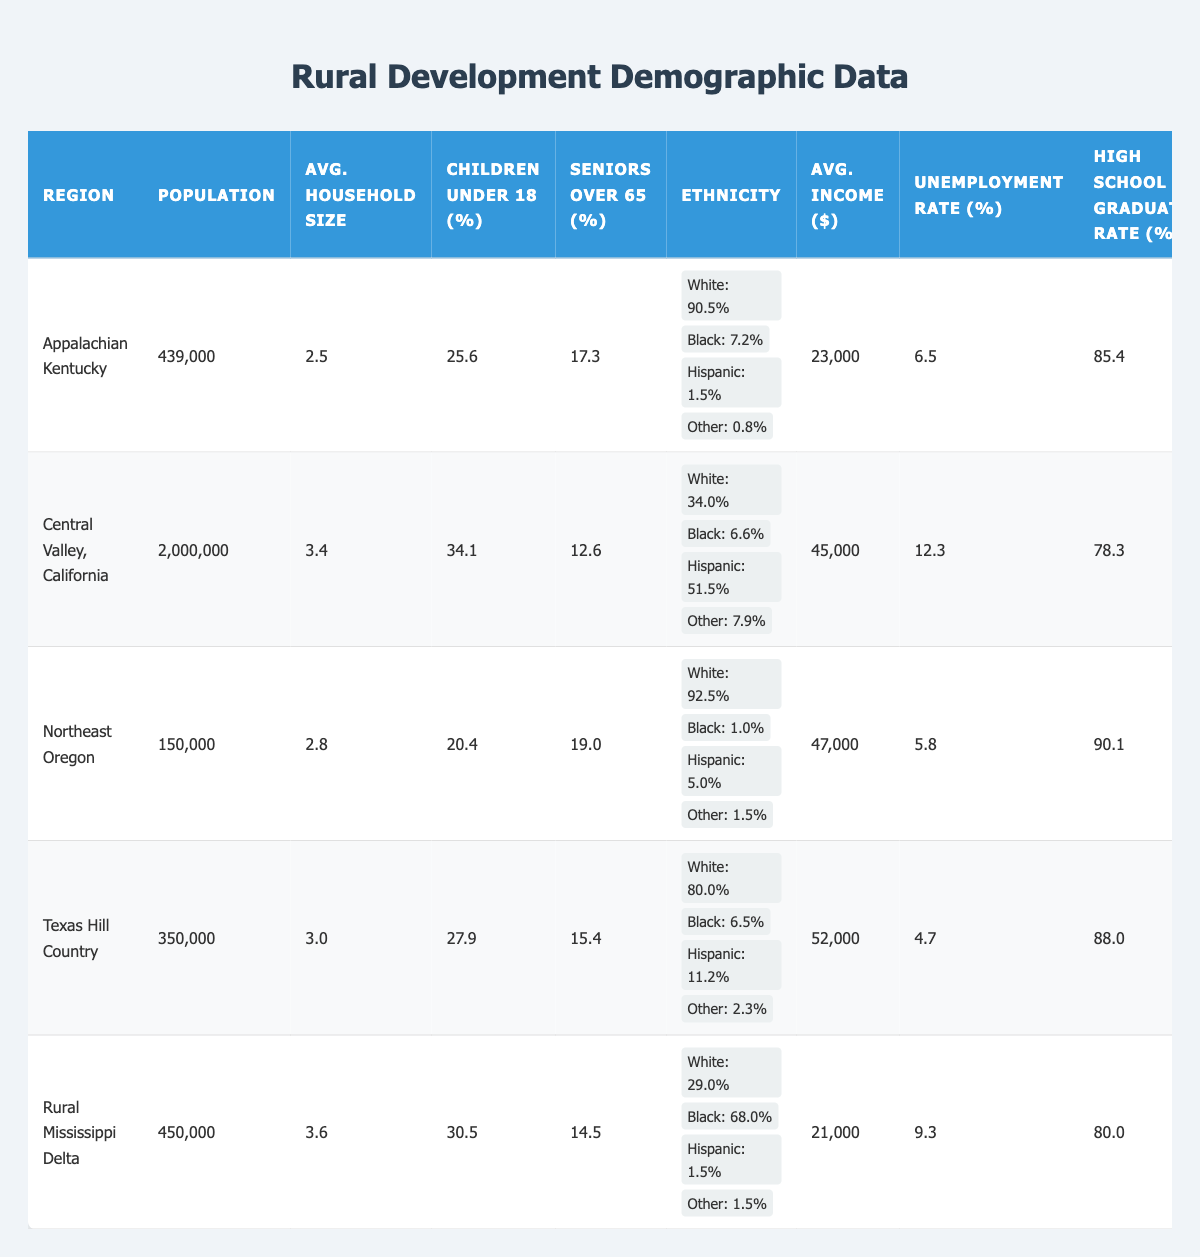What is the population of Central Valley, California? The table lists the population for each region. In the row for Central Valley, California, the population is recorded as 2,000,000.
Answer: 2,000,000 What is the average household size in the Texas Hill Country? Looking at the Texas Hill Country row in the table, the average household size is given as 3.0.
Answer: 3.0 Which region has the highest percentage of children under 18? By comparing the values in the "Children Under 18 (%)" column, the Rural Mississippi Delta has the highest value at 30.5%.
Answer: Rural Mississippi Delta What is the poverty rate in Appalachian Kentucky? Checking the poverty rate for Appalachian Kentucky in the table, it shows a rate of 30.2%.
Answer: 30.2% Which region has the lowest unemployment rate? In the "Unemployment Rate (%)" column, Texas Hill Country shows the lowest rate at 4.7%, which is lower than all other regions.
Answer: Texas Hill Country Is the percentage of seniors over 65 in Northeast Oregon greater than 15%? The table shows that the percentage of seniors over 65 in Northeast Oregon is 19.0%, which is greater than 15%.
Answer: Yes What is the difference in average income between the Central Valley, California and the Rural Mississippi Delta? The average income for Central Valley, California is $45,000 and for Rural Mississippi Delta is $21,000. The difference is calculated as $45,000 - $21,000 = $24,000.
Answer: $24,000 Which region has a higher high school graduation rate: Texas Hill Country or Central Valley, California? The high school graduation rate for Texas Hill Country is 88.0% while Central Valley, California is 78.3%. Since 88.0% is greater than 78.3%, Texas Hill Country has a higher graduation rate.
Answer: Texas Hill Country Calculate the average unemployment rate across all regions. To find the average, sum up the unemployment rates: (6.5 + 12.3 + 5.8 + 4.7 + 9.3) = 38.6, then divide by 5 regions: 38.6 / 5 = 7.72.
Answer: 7.72 Is the percentage of Hispanic individuals in the Texas Hill Country greater than 10%? The table shows that 11.2% of the population in the Texas Hill Country is Hispanic, which is indeed greater than 10%.
Answer: Yes What is the relationship between high school graduation rates and poverty rates in these regions? By observing the graduation rates and corresponding poverty rates, regions with lower poverty rates (Texas Hill Country: 12.9% and Northeast Oregon: 18.2%) tend to have higher graduation rates (88.0% and 90.1%). This indicates a negative correlation.
Answer: Negative correlation 